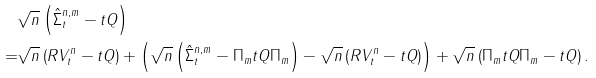Convert formula to latex. <formula><loc_0><loc_0><loc_500><loc_500>& \sqrt { n } \left ( \hat { \Sigma } _ { t } ^ { n , m } - t Q \right ) \\ = & \sqrt { n } \left ( R V _ { t } ^ { n } - t Q \right ) + \left ( \sqrt { n } \left ( \hat { \Sigma } _ { t } ^ { n , m } - \Pi _ { m } t Q \Pi _ { m } \right ) - \sqrt { n } \left ( R V _ { t } ^ { n } - t Q \right ) \right ) + \sqrt { n } \left ( \Pi _ { m } t Q \Pi _ { m } - t Q \right ) .</formula> 